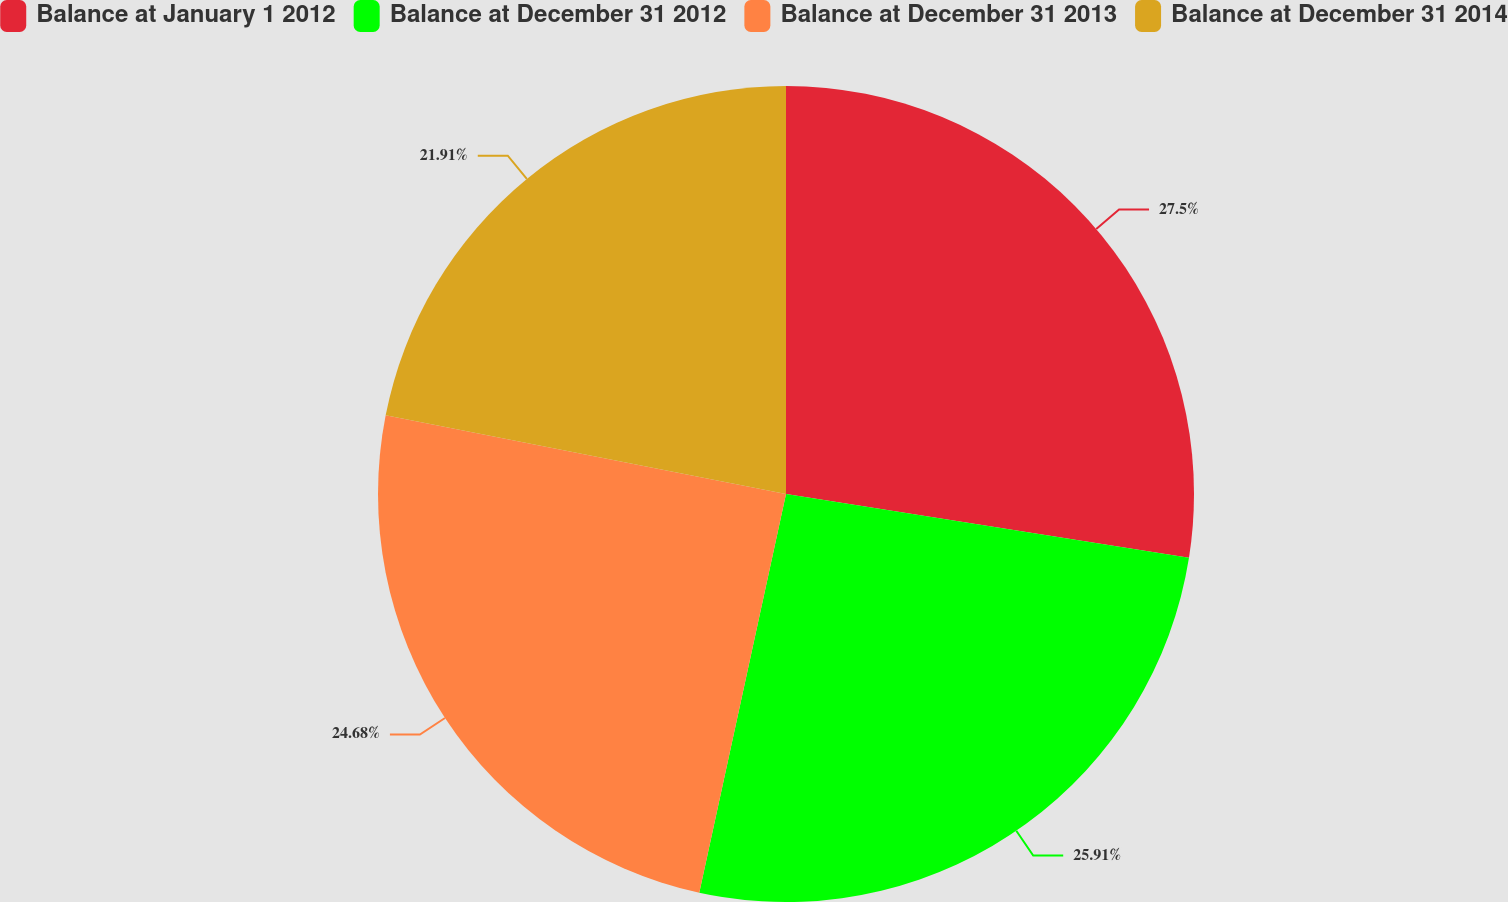Convert chart to OTSL. <chart><loc_0><loc_0><loc_500><loc_500><pie_chart><fcel>Balance at January 1 2012<fcel>Balance at December 31 2012<fcel>Balance at December 31 2013<fcel>Balance at December 31 2014<nl><fcel>27.5%<fcel>25.91%<fcel>24.68%<fcel>21.91%<nl></chart> 